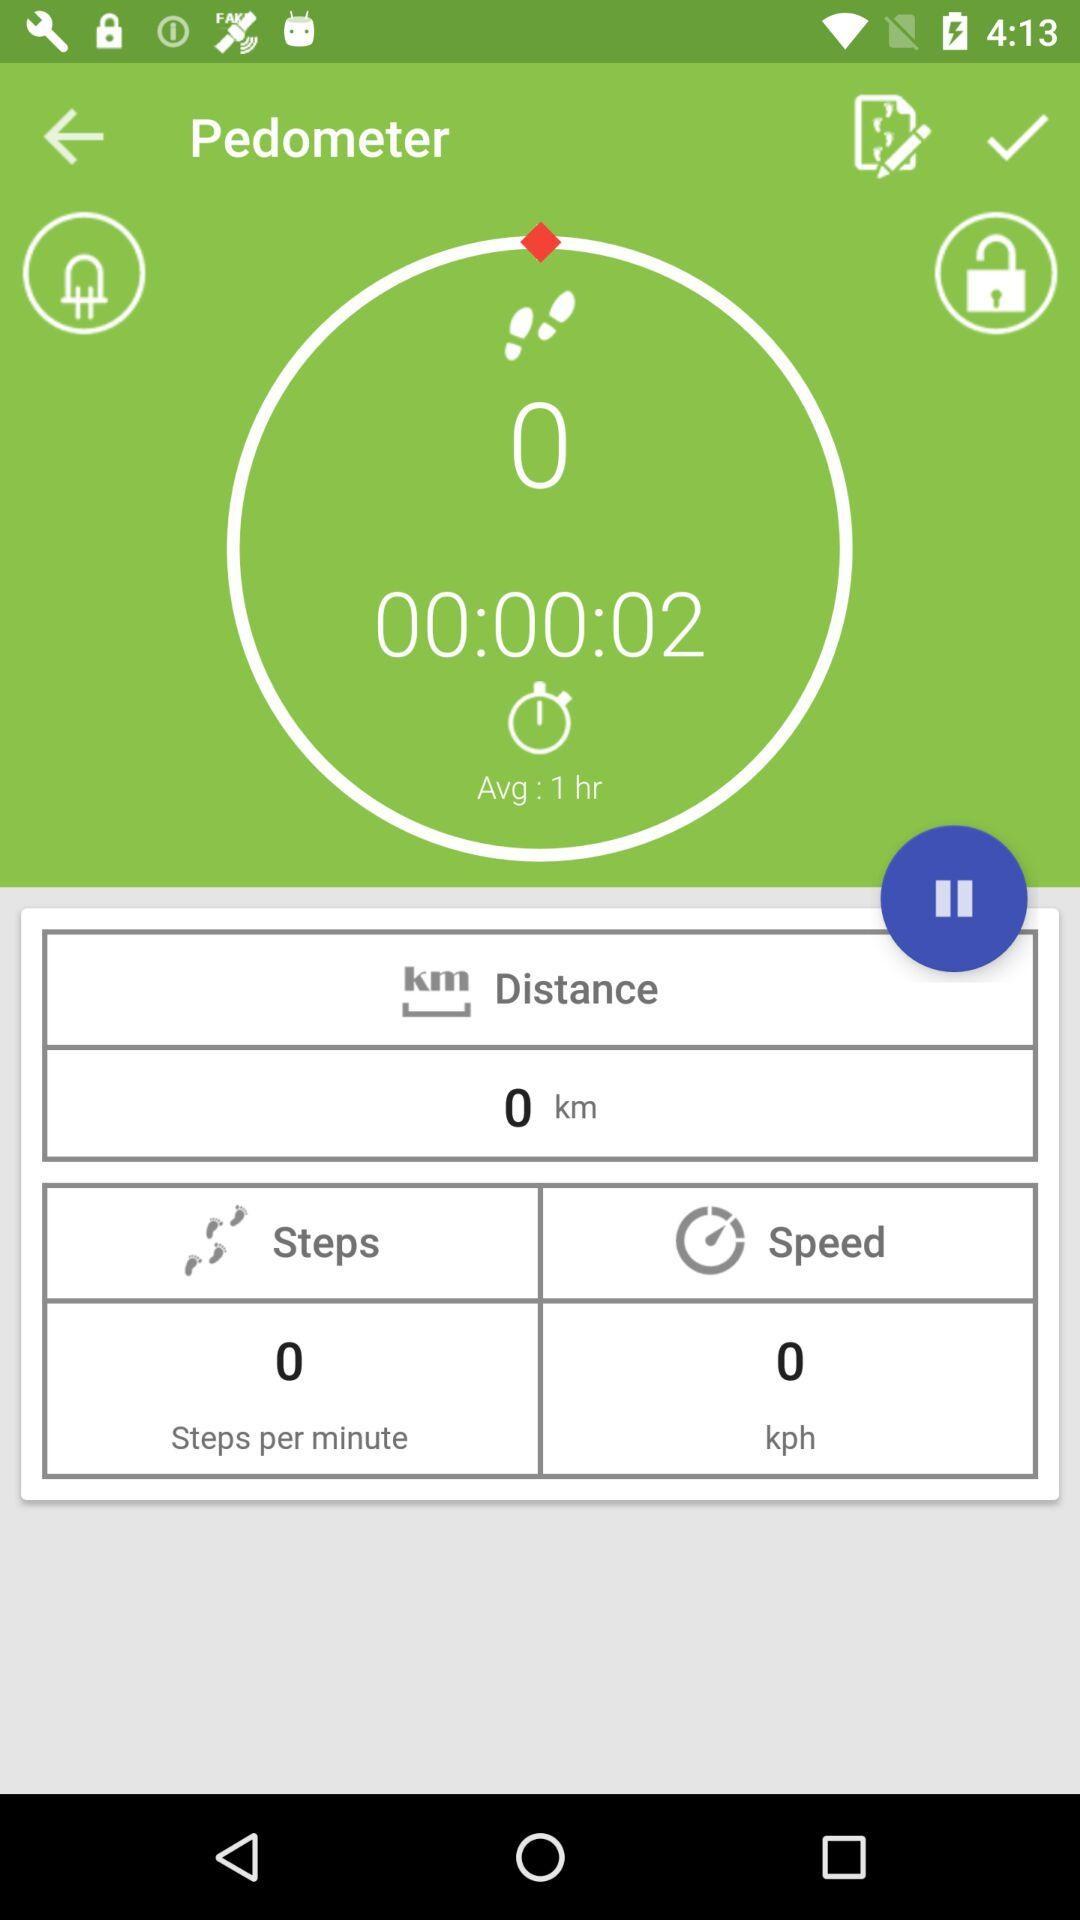How many steps per minute? There are zero steps per minute. 